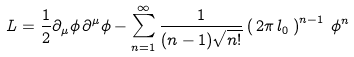Convert formula to latex. <formula><loc_0><loc_0><loc_500><loc_500>L = \frac { 1 } { 2 } \partial _ { \mu } \phi \, \partial ^ { \mu } \phi - \sum _ { n = 1 } ^ { \infty } \frac { 1 } { ( n - 1 ) \sqrt { n ! } } \left ( \, 2 \pi \, l _ { 0 } \, \right ) ^ { n - 1 } \, \phi ^ { n }</formula> 